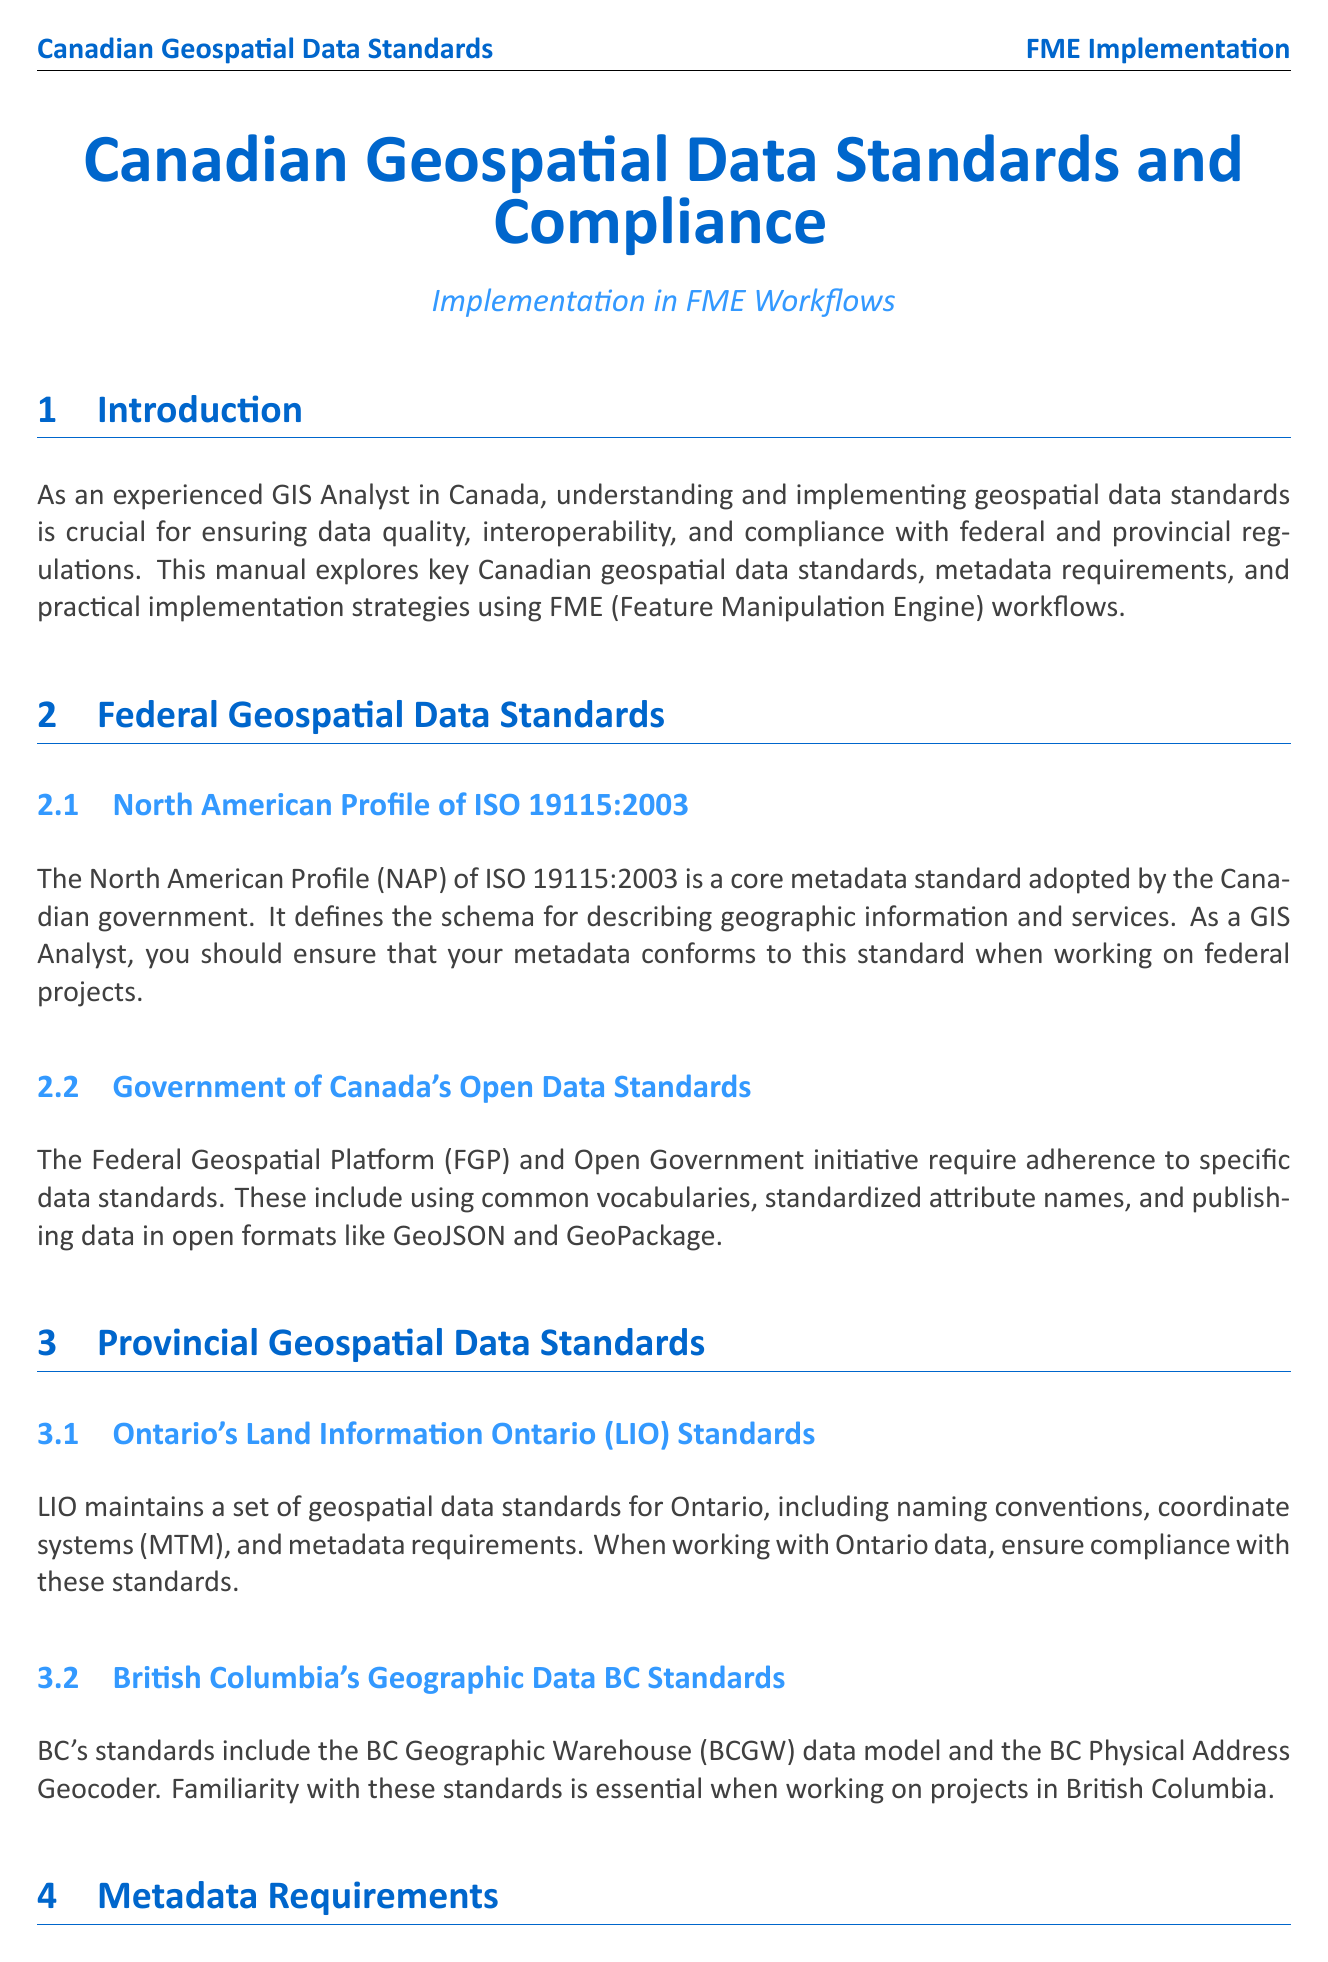What is the title of the manual? The title of the manual is provided in the document header section.
Answer: Canadian Geospatial Data Standards and Compliance: Implementation in FME Workflows What is the core metadata standard adopted by the Canadian government? The core metadata standard is mentioned under the federal standards section.
Answer: North American Profile of ISO 19115:2003 Which province's geospatial data standards include the BC Geographic Warehouse? The document specifies standards for different provinces, mentioning theirs.
Answer: British Columbia What are essential metadata elements? Essential metadata elements are listed within the metadata requirements section.
Answer: title, abstract, date, contact information, geographic extent, coordinate reference system, and data quality information What FME transformer can be used for coordinate system transformation? This information specifies which transformer is relevant for coordinate systems in FME workflows.
Answer: Reprojector What is one of the best practices for FME workspaces according to the document? The best practices section provides a set of recommendations for maintaining FME workspaces.
Answer: Regularly update your FME workspaces to accommodate changes in standards In what context is the CGDI mentioned in the document? CGDI is highlighted in the case study section, illustrating its application in a project.
Answer: Implementing CGDI Standards in a National Park Mapping Project 